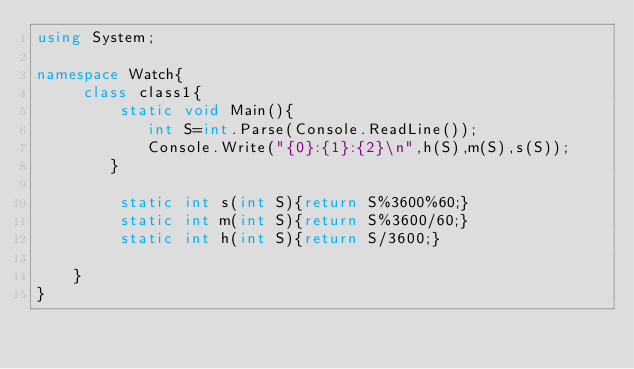Convert code to text. <code><loc_0><loc_0><loc_500><loc_500><_C#_>using System;

namespace Watch{
	 class class1{
		 static void Main(){
			int S=int.Parse(Console.ReadLine());
			Console.Write("{0}:{1}:{2}\n",h(S),m(S),s(S));
		}

		 static int s(int S){return S%3600%60;}
		 static int m(int S){return S%3600/60;}
		 static int h(int S){return S/3600;}	
		
	}
}</code> 